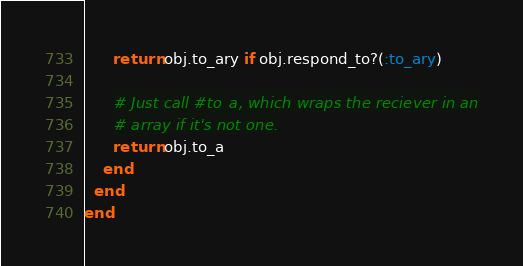<code> <loc_0><loc_0><loc_500><loc_500><_Ruby_>      return obj.to_ary if obj.respond_to?(:to_ary)

      # Just call #to_a, which wraps the reciever in an
      # array if it's not one.
      return obj.to_a
    end
  end
end
</code> 